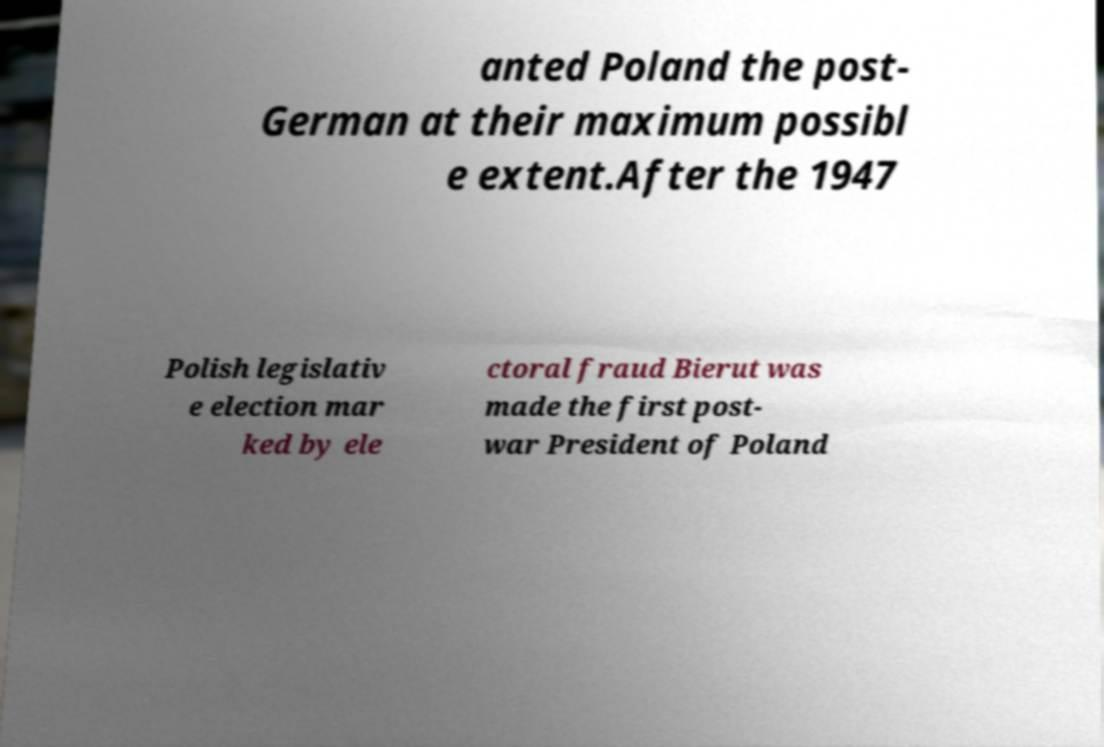Could you extract and type out the text from this image? anted Poland the post- German at their maximum possibl e extent.After the 1947 Polish legislativ e election mar ked by ele ctoral fraud Bierut was made the first post- war President of Poland 